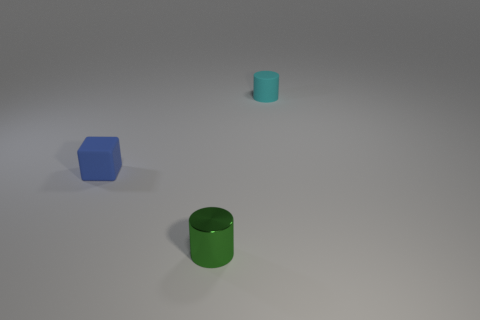How many other things are the same size as the cyan cylinder?
Your response must be concise. 2. Does the cyan cylinder have the same size as the object to the left of the metallic cylinder?
Ensure brevity in your answer.  Yes. There is a thing left of the cylinder that is in front of the object to the left of the green thing; what shape is it?
Offer a terse response. Cube. Are there fewer blocks than matte objects?
Keep it short and to the point. Yes. Are there any small green cylinders in front of the green metal thing?
Offer a terse response. No. There is a object that is right of the block and left of the cyan matte object; what is its shape?
Provide a succinct answer. Cylinder. Are there any other green metal objects that have the same shape as the tiny green metal thing?
Provide a short and direct response. No. Do the cylinder that is behind the rubber cube and the thing left of the shiny cylinder have the same size?
Offer a terse response. Yes. Is the number of large gray things greater than the number of cylinders?
Make the answer very short. No. How many cylinders have the same material as the blue object?
Offer a very short reply. 1. 